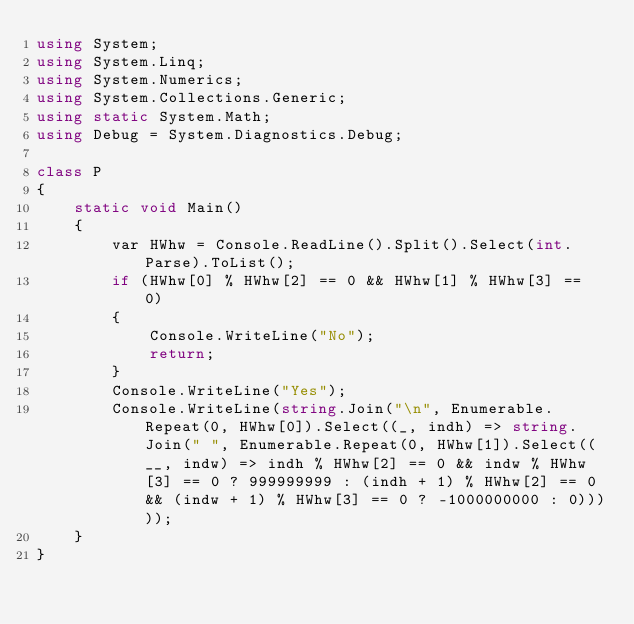Convert code to text. <code><loc_0><loc_0><loc_500><loc_500><_C#_>using System;
using System.Linq;
using System.Numerics;
using System.Collections.Generic;
using static System.Math;
using Debug = System.Diagnostics.Debug;

class P
{
    static void Main()
    {
        var HWhw = Console.ReadLine().Split().Select(int.Parse).ToList();
        if (HWhw[0] % HWhw[2] == 0 && HWhw[1] % HWhw[3] == 0)
        {
            Console.WriteLine("No");
            return;
        }
        Console.WriteLine("Yes");
        Console.WriteLine(string.Join("\n", Enumerable.Repeat(0, HWhw[0]).Select((_, indh) => string.Join(" ", Enumerable.Repeat(0, HWhw[1]).Select((__, indw) => indh % HWhw[2] == 0 && indw % HWhw[3] == 0 ? 999999999 : (indh + 1) % HWhw[2] == 0 && (indw + 1) % HWhw[3] == 0 ? -1000000000 : 0)))));
    }
}

</code> 